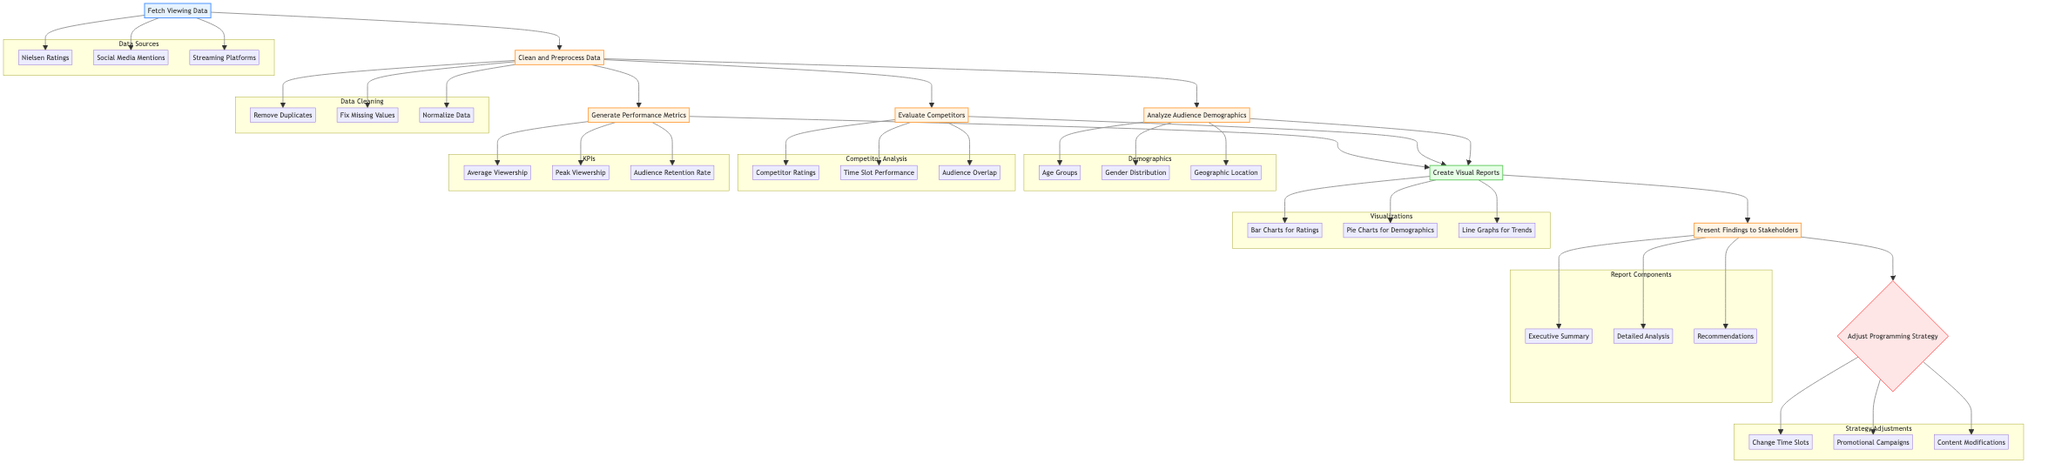What is the first step in the flowchart? The first step, identified in the flowchart, is labeled "Fetch Viewing Data," which indicates it is the initial action required.
Answer: Fetch Viewing Data How many processes are there in total? By counting the nodes labeled as processes, we find there are five processes: "Clean and Preprocess Data," "Analyze Audience Demographics," "Evaluate Competitors," "Generate Performance Metrics," and "Present Findings to Stakeholders."
Answer: Five What follows after cleaning and preprocessing data? After the "Clean and Preprocess Data" node, the diagram shows arrows leading to "Analyze Audience Demographics," "Evaluate Competitors," and "Generate Performance Metrics," indicating these processes occur next.
Answer: Analyze Audience Demographics, Evaluate Competitors, Generate Performance Metrics What types of visual reports are created? The outputs specified in the flowchart for visual reports include "Bar Charts for Ratings," "Pie Charts for Demographics," and "Line Graphs for Trends."
Answer: Bar Charts for Ratings, Pie Charts for Demographics, Line Graphs for Trends Which component requires stakeholder presentation? The diagram explicitly states that the "Present Findings to Stakeholders" process is responsible for sharing the report components and findings with stakeholders.
Answer: Present Findings to Stakeholders What comes before generating performance metrics? The node immediately preceding "Generate Performance Metrics" is part of the processes that follow the "Clean and Preprocess Data" step, specifically needing insights from "Analyze Audience Demographics," "Evaluate Competitors," and data cleaning processes.
Answer: Clean and Preprocess Data What are the possible adjustments to the programming strategy? The flowchart outlines three potential adjustments to the programming strategy: "Change Time Slots," "Promotional Campaigns," and "Content Modifications."
Answer: Change Time Slots, Promotional Campaigns, Content Modifications How are the data sources organized in the diagram? The "Data Sources" are included in a subgraph that lists three components: "Nielsen Ratings," "Social Media Mentions," and "Streaming Platforms," which represent where viewing data is gathered from.
Answer: Nielsen Ratings, Social Media Mentions, Streaming Platforms What is the final decision step after presenting the findings? After the "Present Findings to Stakeholders" process, the flowchart leads to a decision node titled "Adjust Programming Strategy," indicating the need to make decisions based on the findings presented.
Answer: Adjust Programming Strategy 